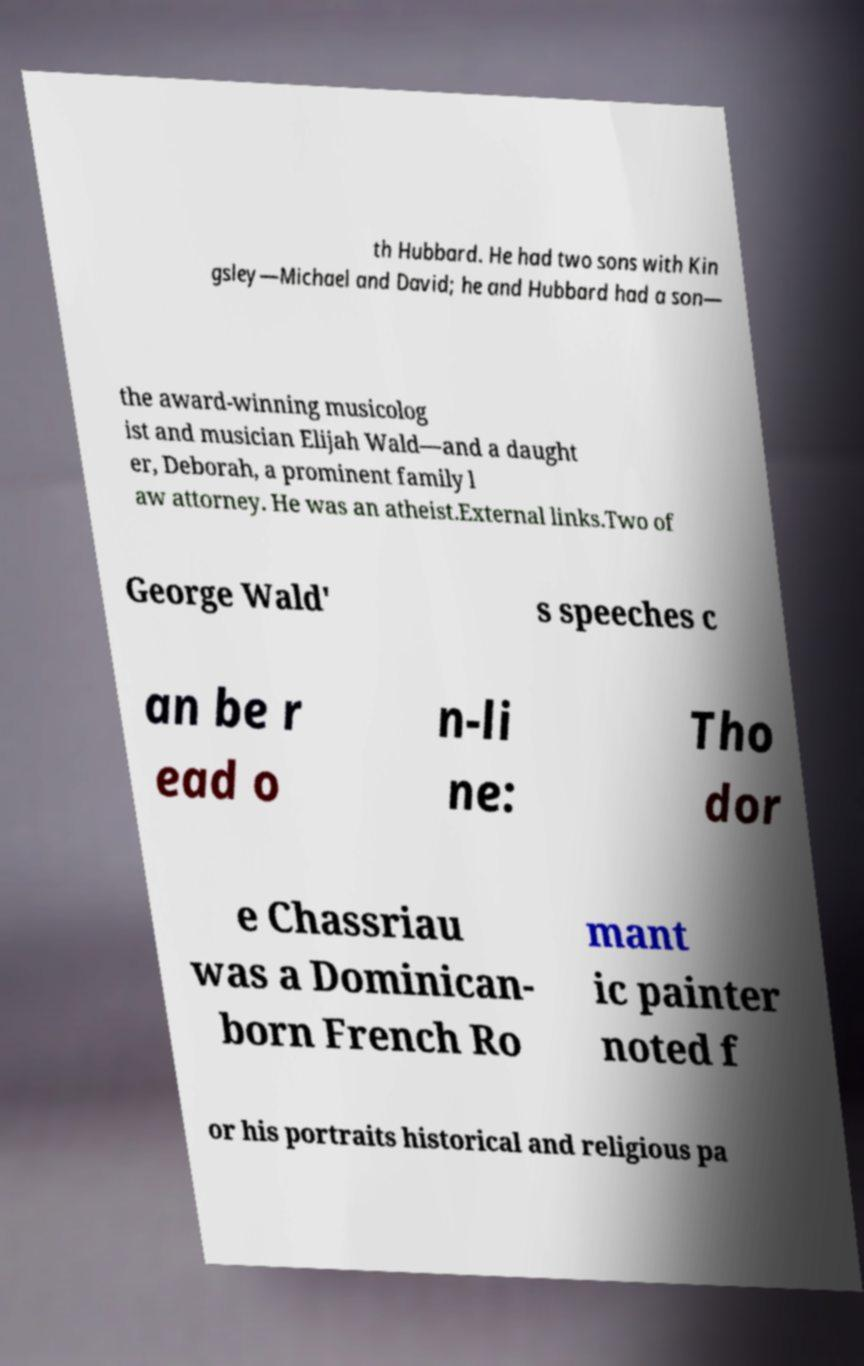Please read and relay the text visible in this image. What does it say? th Hubbard. He had two sons with Kin gsley—Michael and David; he and Hubbard had a son— the award-winning musicolog ist and musician Elijah Wald—and a daught er, Deborah, a prominent family l aw attorney. He was an atheist.External links.Two of George Wald' s speeches c an be r ead o n-li ne: Tho dor e Chassriau was a Dominican- born French Ro mant ic painter noted f or his portraits historical and religious pa 